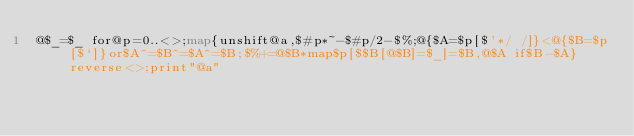Convert code to text. <code><loc_0><loc_0><loc_500><loc_500><_Perl_>@$_=$_ for@p=0..<>;map{unshift@a,$#p*~-$#p/2-$%;@{$A=$p[$'*/ /]}<@{$B=$p[$`]}or$A^=$B^=$A^=$B;$%+=@$B*map$p[$$B[@$B]=$_]=$B,@$A if$B-$A}reverse<>;print"@a"</code> 